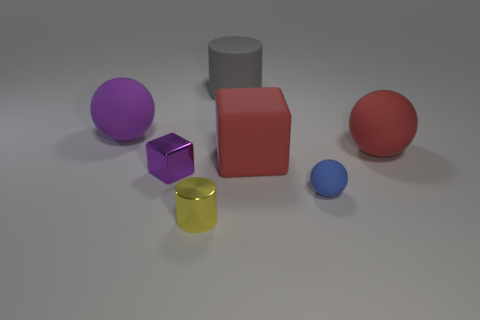Are there more balls behind the blue matte ball than small purple metal blocks?
Provide a succinct answer. Yes. How many other objects are the same color as the shiny cube?
Keep it short and to the point. 1. What shape is the gray object that is the same size as the purple rubber ball?
Make the answer very short. Cylinder. How many large red rubber balls are right of the large red object that is behind the cube right of the tiny purple thing?
Your answer should be very brief. 0. What number of rubber things are large purple spheres or cyan blocks?
Ensure brevity in your answer.  1. What is the color of the tiny thing that is behind the yellow cylinder and to the left of the red block?
Ensure brevity in your answer.  Purple. There is a sphere that is to the left of the gray rubber thing; is its size the same as the small yellow shiny cylinder?
Make the answer very short. No. How many objects are either big objects that are to the right of the blue matte thing or cyan metallic objects?
Your answer should be very brief. 1. Are there any yellow matte balls that have the same size as the shiny cylinder?
Your answer should be compact. No. There is a purple cube that is the same size as the blue matte thing; what is its material?
Make the answer very short. Metal. 